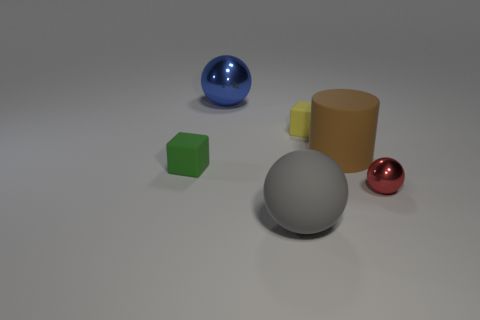Add 3 red metallic balls. How many objects exist? 9 Subtract all blocks. How many objects are left? 4 Subtract 1 yellow cubes. How many objects are left? 5 Subtract all yellow matte objects. Subtract all cyan objects. How many objects are left? 5 Add 1 large shiny spheres. How many large shiny spheres are left? 2 Add 4 red shiny spheres. How many red shiny spheres exist? 5 